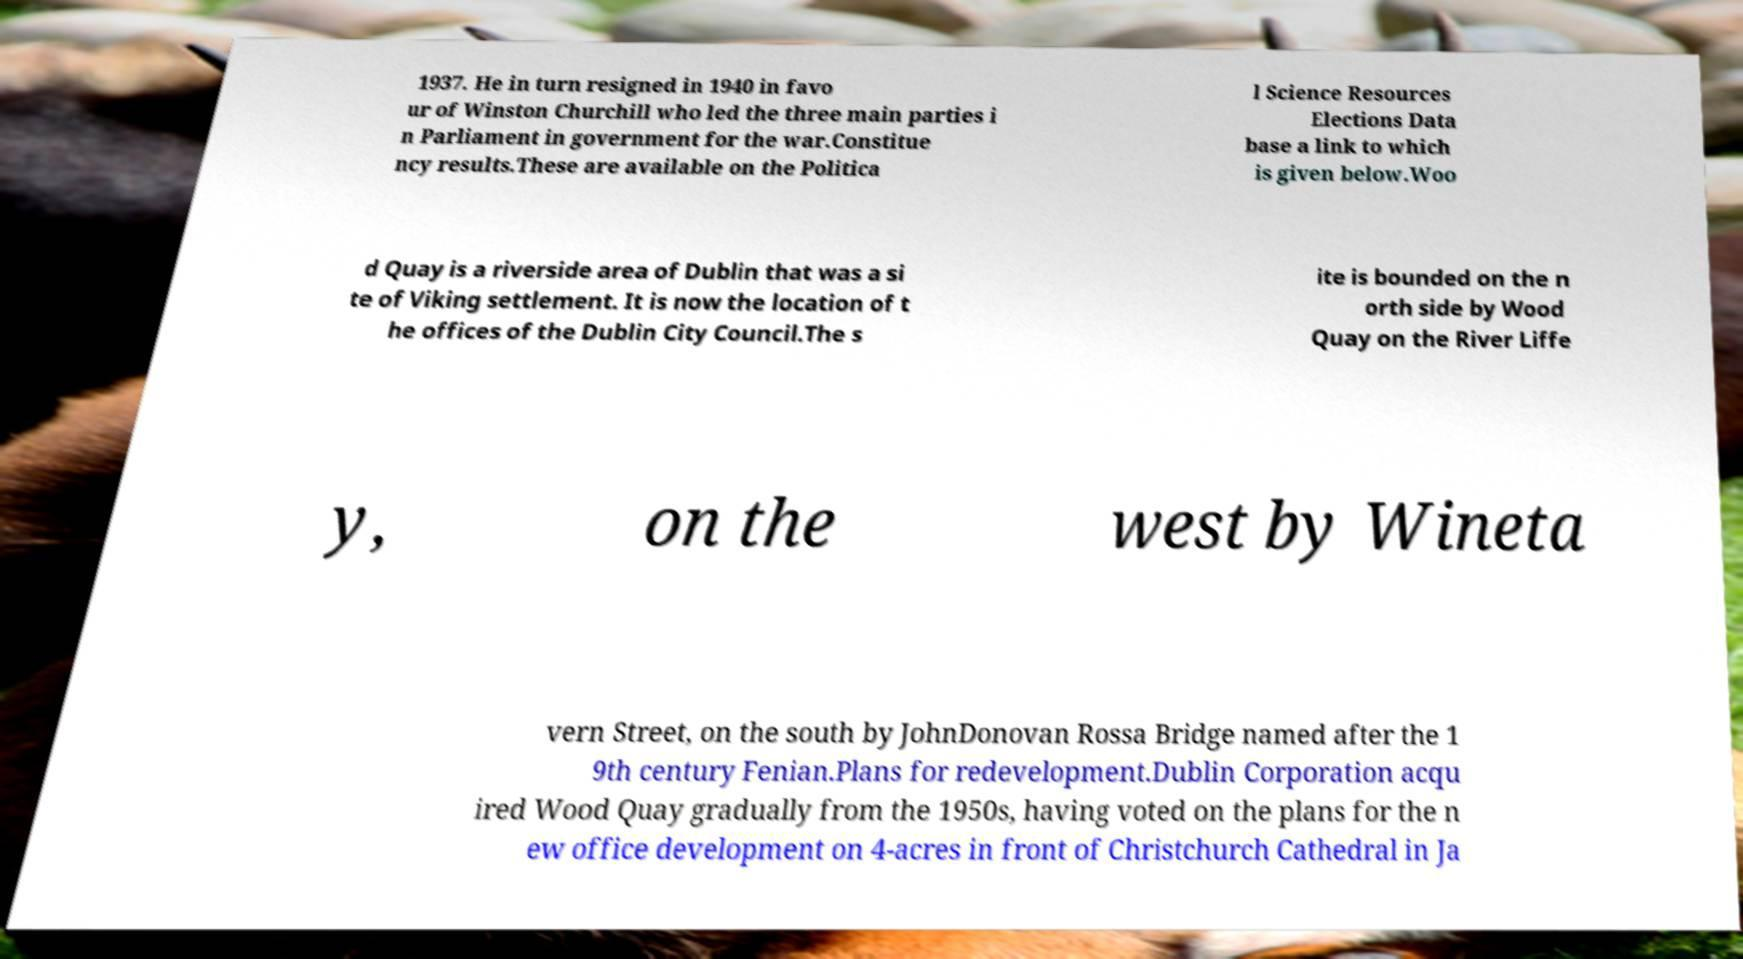Can you read and provide the text displayed in the image?This photo seems to have some interesting text. Can you extract and type it out for me? 1937. He in turn resigned in 1940 in favo ur of Winston Churchill who led the three main parties i n Parliament in government for the war.Constitue ncy results.These are available on the Politica l Science Resources Elections Data base a link to which is given below.Woo d Quay is a riverside area of Dublin that was a si te of Viking settlement. It is now the location of t he offices of the Dublin City Council.The s ite is bounded on the n orth side by Wood Quay on the River Liffe y, on the west by Wineta vern Street, on the south by JohnDonovan Rossa Bridge named after the 1 9th century Fenian.Plans for redevelopment.Dublin Corporation acqu ired Wood Quay gradually from the 1950s, having voted on the plans for the n ew office development on 4-acres in front of Christchurch Cathedral in Ja 